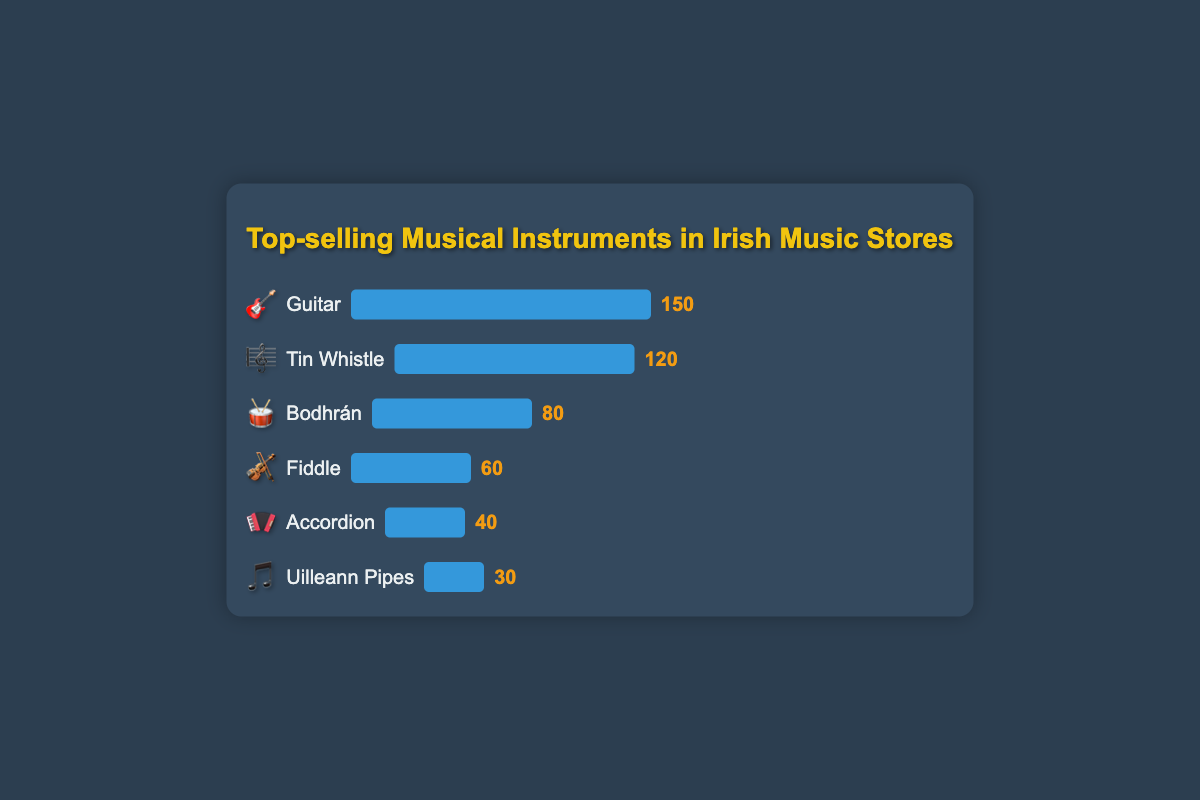What instrument has the highest sales? To determine which instrument has the highest sales, look for the instrument with the longest bar and highest sales number in the figure. The bar and sales number for Guitar (150) is the most prominent.
Answer: Guitar How many more units did the Tin Whistle sell compared to the Accordion? To find the difference in sales between the Tin Whistle and the Accordion, subtract the Accordion's sales (40) from the Tin Whistle's sales (120). Thus, 120 - 40 = 80.
Answer: 80 Which instrument has the least sales? To find the instrument with the lowest sales, look for the instrument with the shortest bar and smallest sales number. The Uilleann Pipes (30) have the least sales.
Answer: Uilleann Pipes Rank the instruments by sales from highest to lowest. By observing the lengths of the bars and corresponding sales numbers, the ranking from highest to lowest sales is: Guitar (150), Tin Whistle (120), Bodhrán (80), Fiddle (60), Accordion (40), Uilleann Pipes (30).
Answer: Guitar, Tin Whistle, Bodhrán, Fiddle, Accordion, Uilleann Pipes What is the combined sales total for traditional Irish instruments (Bodhrán, Tin Whistle, Fiddle, Uilleann Pipes, and Accordion)? To find the total sales of traditional Irish instruments, add their sales together: Bodhrán (80) + Tin Whistle (120) + Fiddle (60) + Uilleann Pipes (30) + Accordion (40). So, 80 + 120 + 60 + 30 + 40 = 330.
Answer: 330 Which instrument has exactly half the sales of the top-selling instrument? The top-selling instrument is the Guitar with 150 units. Half of 150 is 75. The Bodhrán, with 80 sales, is the closest and is slightly more than half. No instrument has exactly half sales.
Answer: None How does the sales number for the Tin Whistle compare to that of the Bodhrán? By comparing the sales numbers directly, the Tin Whistle (120) has higher sales than the Bodhrán (80).
Answer: Tin Whistle has higher sales What is the average sales number of all the instruments? To find the average sales, sum all the sales numbers and divide by the number of instruments: (150 + 80 + 120 + 60 + 30 + 40) / 6 = 480 / 6 = 80.
Answer: 80 